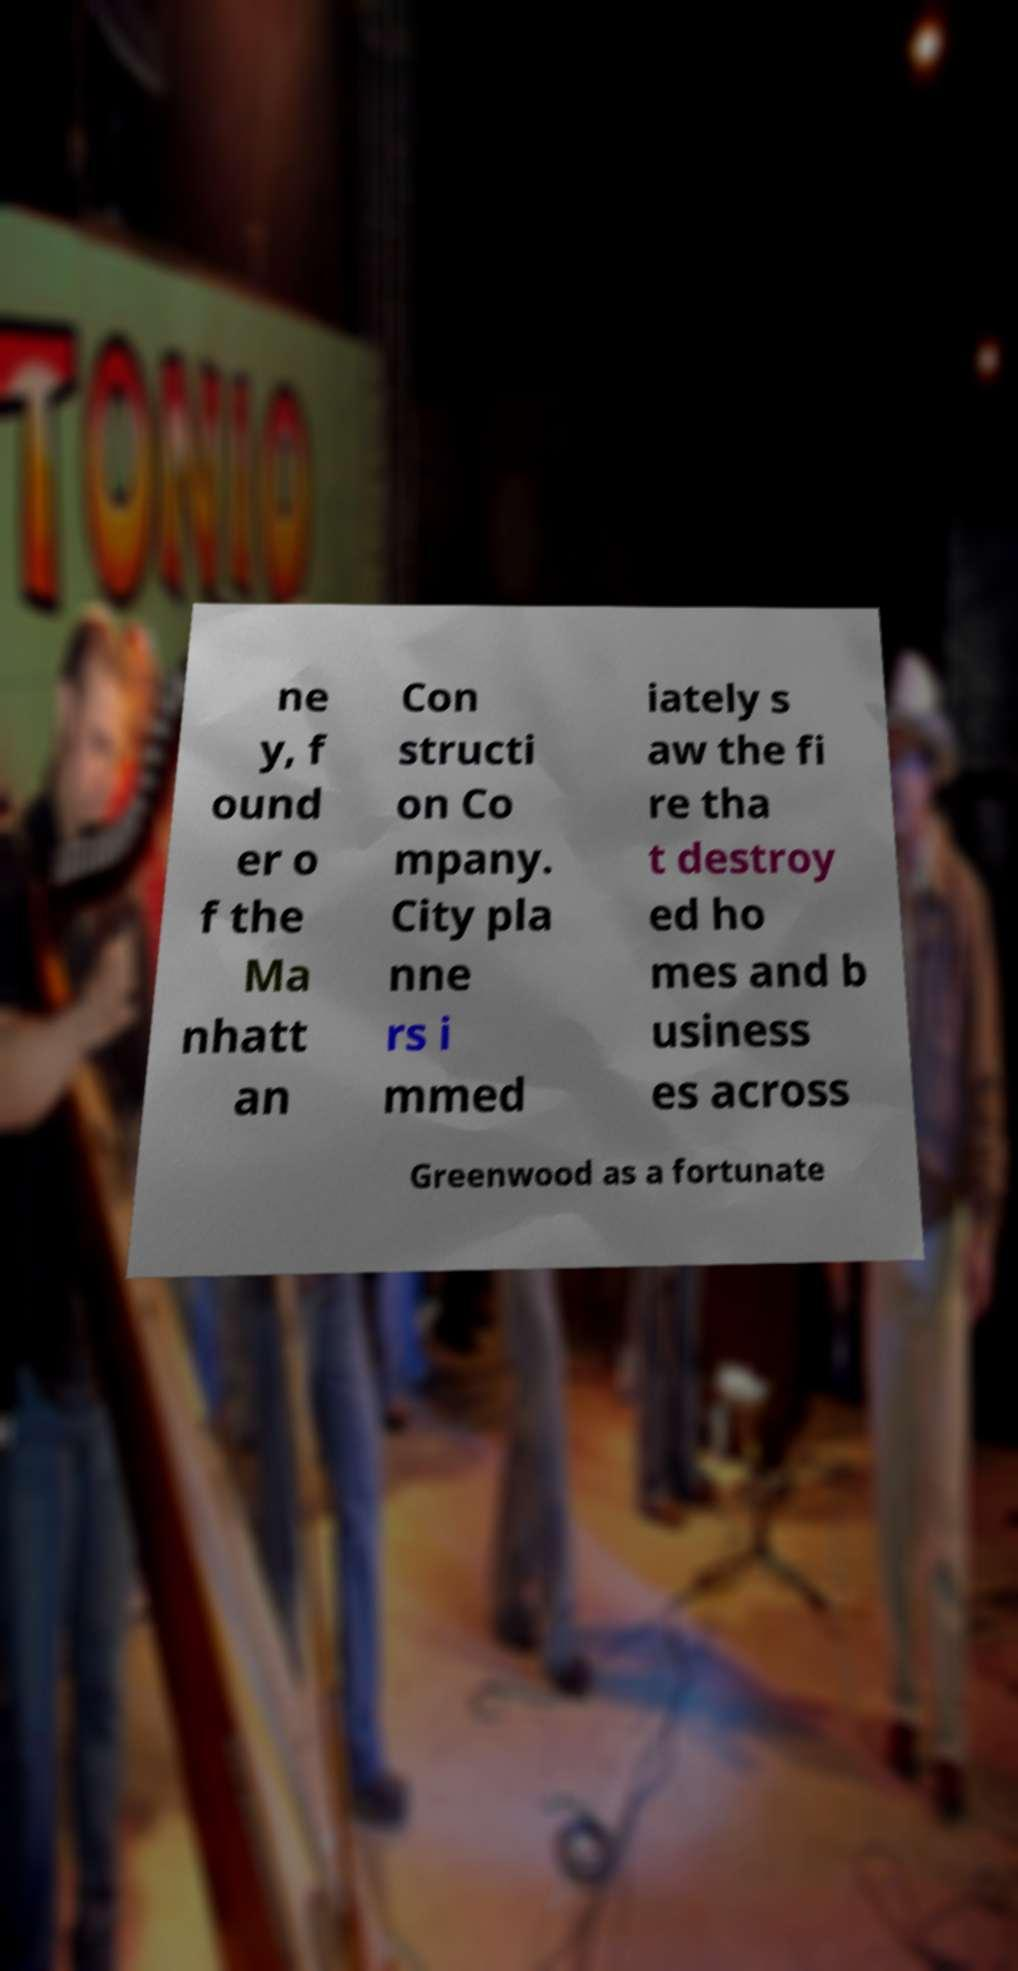Could you extract and type out the text from this image? ne y, f ound er o f the Ma nhatt an Con structi on Co mpany. City pla nne rs i mmed iately s aw the fi re tha t destroy ed ho mes and b usiness es across Greenwood as a fortunate 